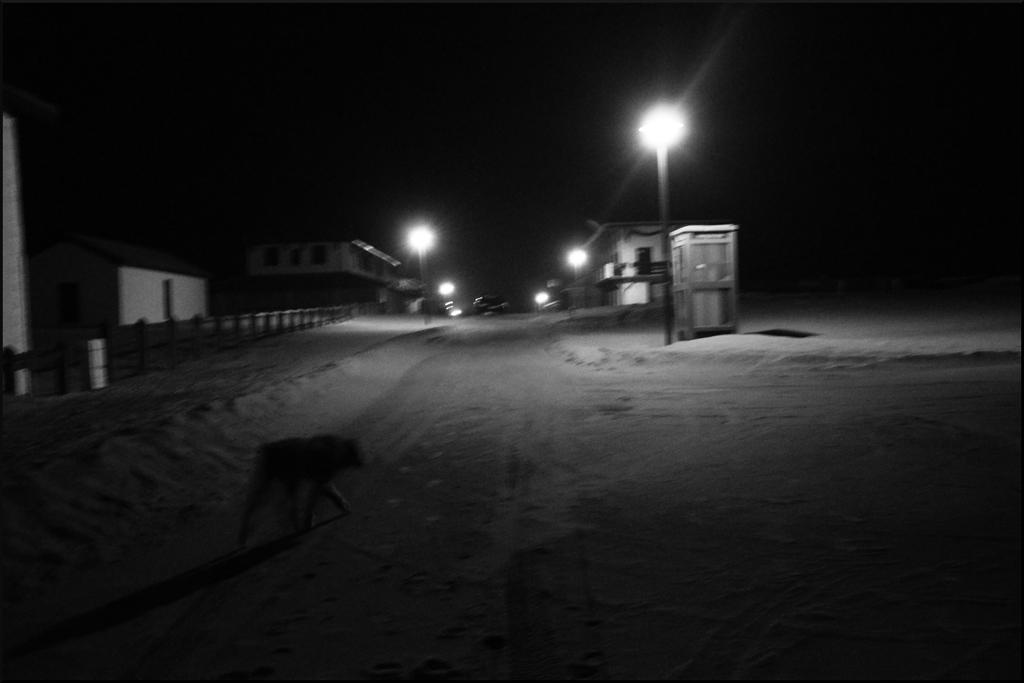What type of animal is in the image? The type of animal cannot be determined from the provided facts. What structures are present in the image? There are houses, poles, and a fence in the image. What is attached to the poles in the image? Lights are attached to the poles in the image. What is the color of the background in the image? The background of the image is dark. What type of riddle is the animal solving in the image? There is no riddle present in the image, and the animal is not shown solving any riddle. What color is the glove that the animal is wearing in the image? There is no glove present in the image, and the animal is not shown wearing any glove. 